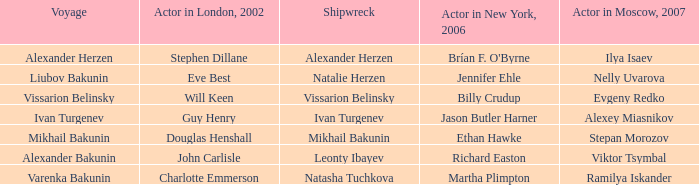Who was the 2007 actor from Moscow for the voyage of Varenka Bakunin? Ramilya Iskander. 